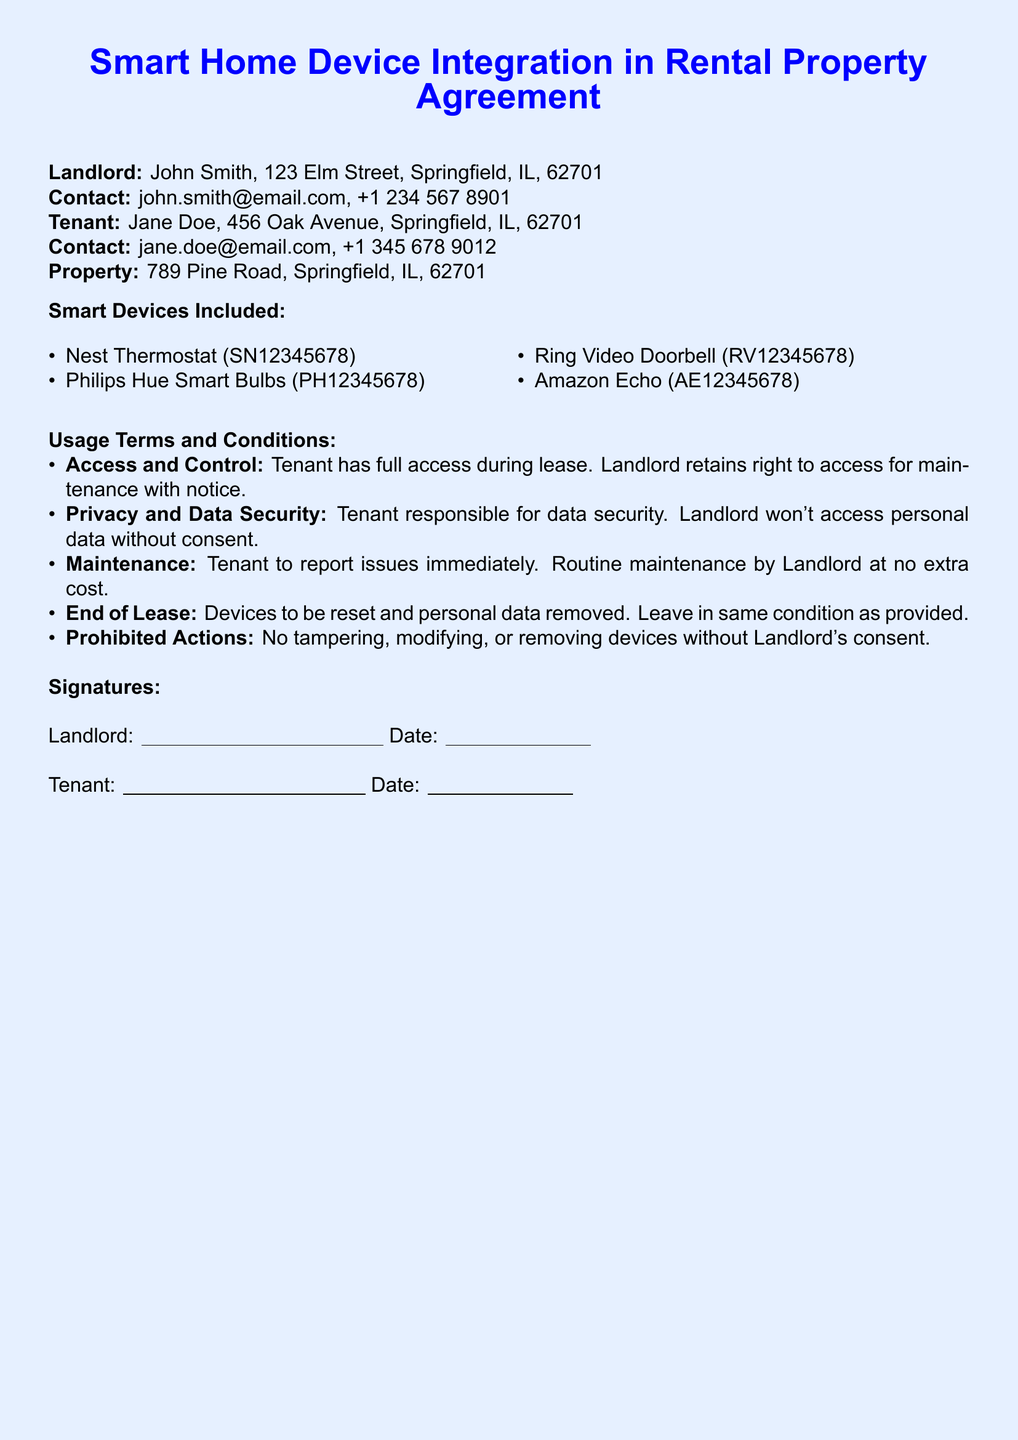What is the name of the landlord? The landlord's name is listed as John Smith in the document.
Answer: John Smith What is the tenant's email address? The document provides the tenant's contact information, including their email address, which is stated as jane.doe@email.com.
Answer: jane.doe@email.com How many smart devices are included in the property? The document lists four specific smart devices included in the rental property agreement.
Answer: Four What should the tenant do if there is an issue with a device? The usage terms state that the tenant must report issues immediately to the landlord.
Answer: Report immediately Can the tenant modify the smart devices? The usage terms specify that the tenant cannot tamper, modify, or remove devices without the landlord's consent.
Answer: No What information is the landlord required to provide before accessing the devices? The landlord must give notice before accessing the devices for maintenance as outlined in the terms.
Answer: Notice What is the address of the rental property? The property address is clearly stated in the document as 789 Pine Road, Springfield, IL, 62701.
Answer: 789 Pine Road, Springfield, IL, 62701 What must the tenant do with personal data at the end of the lease? The terms specify that the tenant must remove personal data and reset the devices at the end of the lease.
Answer: Remove personal data and reset devices 